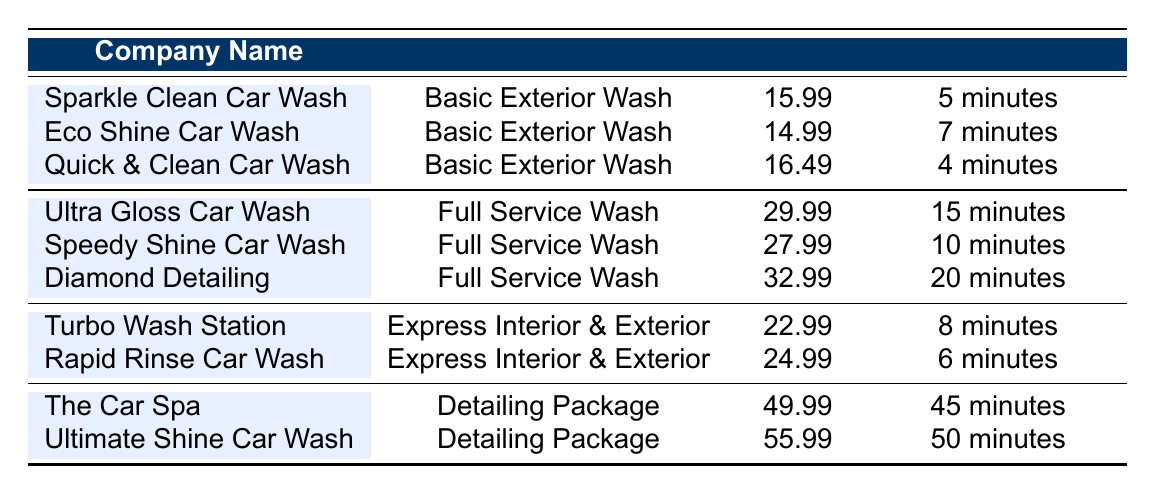What is the price of the Full Service Wash at Speedy Shine Car Wash? The table lists the service types and their corresponding prices. "Speedy Shine Car Wash" provides a "Full Service Wash," which is priced at 27.99.
Answer: 27.99 What is the average turnaround time for Basic Exterior Wash services? From the table, there are three listings for "Basic Exterior Wash" with the following turnaround times: 5 minutes (Sparkle Clean), 7 minutes (Eco Shine), and 4 minutes (Quick & Clean). To find the average, we add these times together (5 + 7 + 4 = 16 minutes) and then divide by 3 (16/3 = 5.33). The average turnaround time is approximately 5.33 minutes.
Answer: Approximately 5.33 minutes Which service has the highest price? The table shows several services with different prices. The "Ultimate Shine Car Wash" has the highest price listed at 55.99.
Answer: 55.99 Is the price of the Basic Exterior Wash at Eco Shine Car Wash lower than at Sparkle Clean Car Wash? According to the table, the price for Eco Shine Car Wash is 14.99, while for Sparkle Clean Car Wash it is 15.99. Thus, 14.99 is indeed lower than 15.99.
Answer: Yes How much cheaper is the Express Interior & Exterior service at Turbo Wash Station compared to Rapid Rinse Car Wash? Turbo Wash Station charges 22.99 for the service, and Rapid Rinse Car Wash charges 24.99. To find the difference, we subtract 22.99 from 24.99 (24.99 - 22.99 = 2). The Express Interior & Exterior service at Turbo Wash Station is 2 cheaper than at Rapid Rinse Car Wash.
Answer: 2 Which car wash offers the quickest turnaround time for a Basic Exterior Wash? By comparing the turnaround times for "Basic Exterior Wash," Quick & Clean Car Wash offers the quickest service at 4 minutes, while Sparkle Clean takes 5 minutes and Eco Shine takes 7 minutes.
Answer: Quick & Clean Car Wash Does Diamond Detailing have the same turnaround time as Speedy Shine Car Wash for their Full Service Wash? The table indicates that Diamond Detailing has a turnaround time of 20 minutes while Speedy Shine Car Wash has a turnaround time of 10 minutes. Therefore, the two services do not have the same turnaround time.
Answer: No What is the total price for the Basic Exterior Wash and the Full Service Wash from Sparkle Clean Car Wash? The price of the Basic Exterior Wash at Sparkle Clean is 15.99, and the Full Service Wash is not applicable to Sparkle Clean. Since it only offers Basic Exterior Wash, the total price for available services at Sparkle Clean would only count the Basic Exterior Wash price, thus, no addition here.
Answer: 15.99 